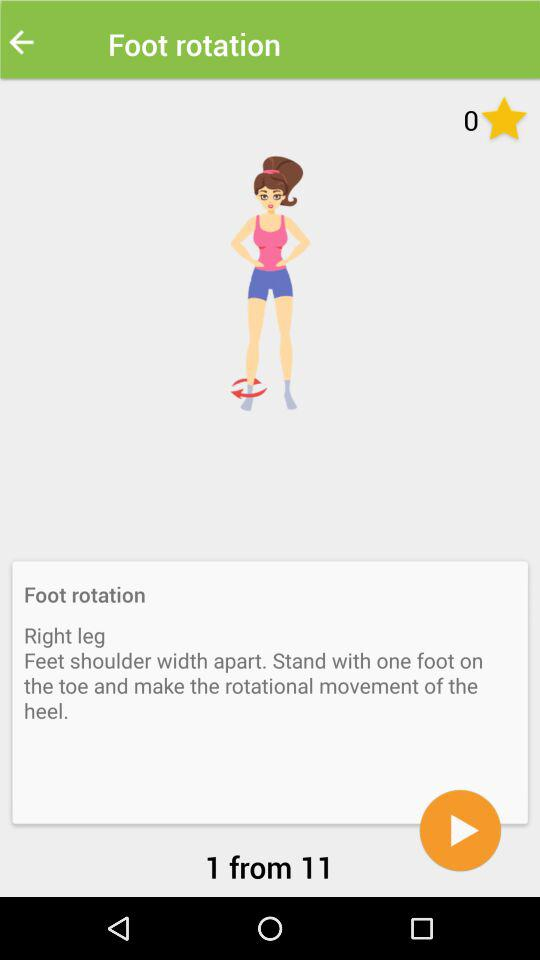How many steps are there in this exercise?
Answer the question using a single word or phrase. 11 